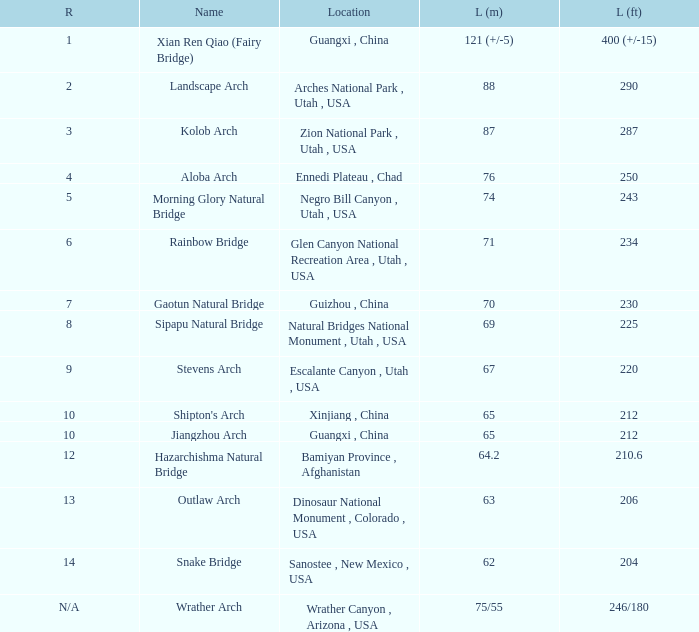What is the length in feet of the Jiangzhou arch? 212.0. 